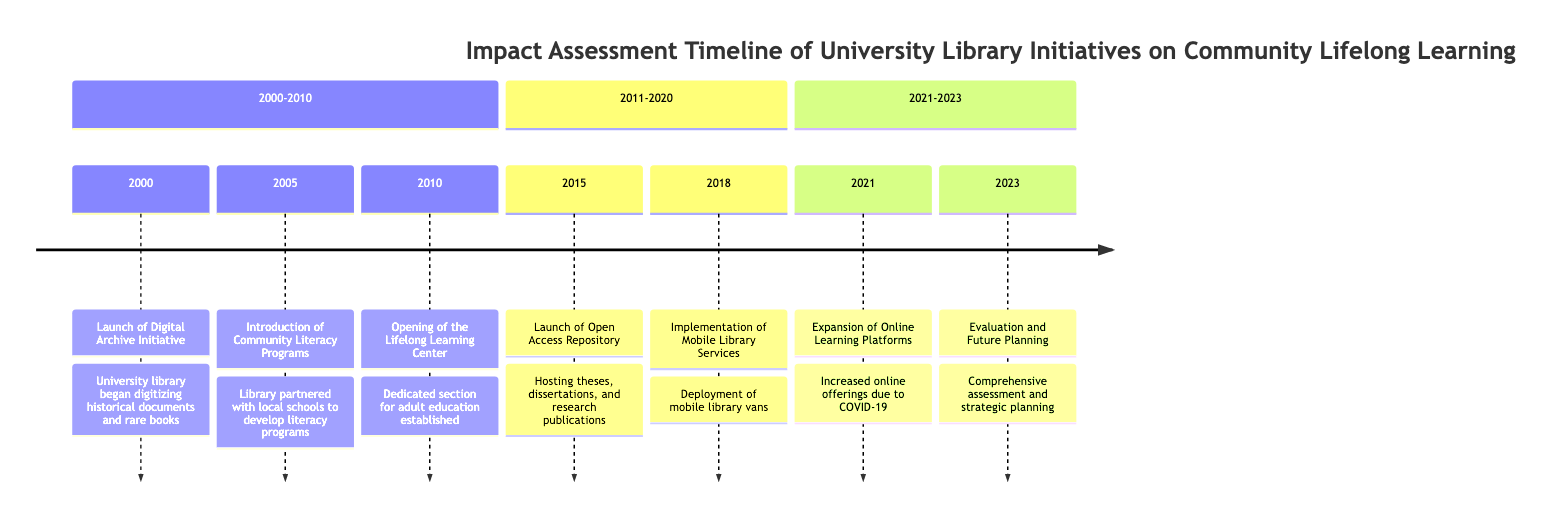What year did the library launch the Digital Archive Initiative? The diagram indicates that the Digital Archive Initiative was launched in the year 2000. This is explicitly stated in the corresponding event section of the timeline.
Answer: 2000 Which initiative aimed specifically at adult education was opened in 2010? The event for 2010 specifies the "Opening of the Lifelong Learning Center," which provides resources and workshops targeting adult education. Thus, it is the initiative opened in that year.
Answer: Lifelong Learning Center How many significant events are there in total from 2000 to 2023? By counting the events listed in the timeline, there are a total of seven significant events presented, one for each year specified.
Answer: 7 What service was implemented in 2018 to reach underserved communities? The event described for 2018 is the "Implementation of Mobile Library Services," which indicates the service aimed at reaching underserved communities.
Answer: Mobile Library Services In which year did the library launch the Open Access Repository? The timeline specifically mentions the launch of the Open Access Repository occurring in the year 2015, making it a clear target year for that particular initiative.
Answer: 2015 What impact did the COVID-19 pandemic have on the library's services? According to the 2021 event, the library "Expansion of Online Learning Platforms" was a direct response to the COVID-19 pandemic, indicating it significantly increased online offerings.
Answer: Increased online offerings Which two initiatives occurred in the years 2010 and 2015? The events for 2010 and 2015 are the "Opening of the Lifelong Learning Center" and the "Launch of Open Access Repository," respectively, and these two initiatives directly address adult education and access to academic research.
Answer: Lifelong Learning Center and Open Access Repository What was the primary focus of the library's initiatives according to the timeline? The focus of the initiatives illustrated in the timeline revolves around enhancing community lifelong learning through various programs, services, and platforms.
Answer: Community lifelong learning What led to the Evaluation and Future Planning event in 2023? The event in 2023 involved a comprehensive assessment of the library’s impact on community lifelong learning, which naturally suggests improvement and strategic planning based on previous initiatives from 2000 to 2021.
Answer: Assessment of impact 